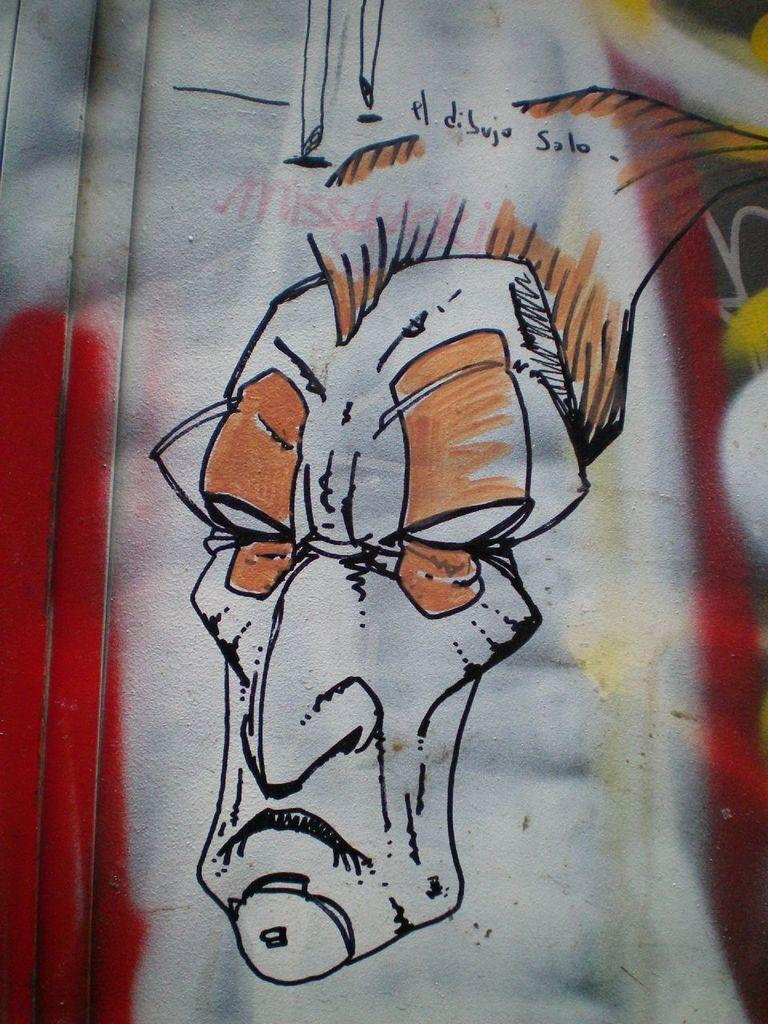What is depicted in the image? There is a painting of a man in the image. What type of zipper is used to hold the painting together? There is no zipper present in the image, as it is a painting of a man and not a physical object. 